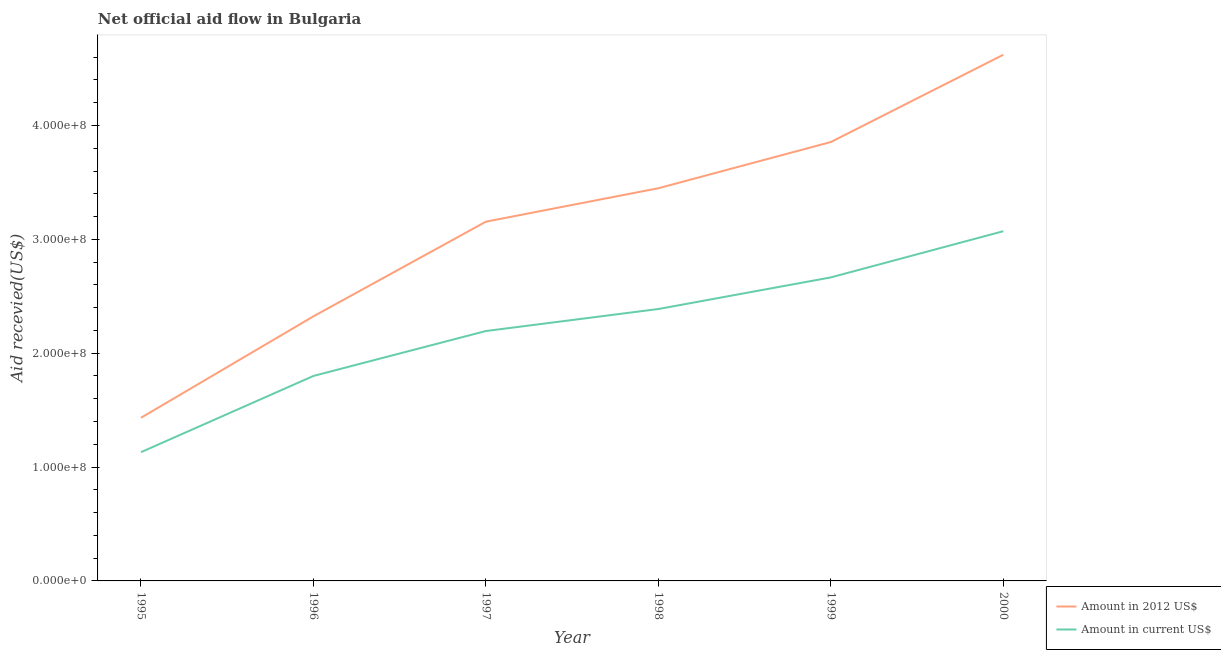Does the line corresponding to amount of aid received(expressed in 2012 us$) intersect with the line corresponding to amount of aid received(expressed in us$)?
Offer a very short reply. No. What is the amount of aid received(expressed in us$) in 2000?
Offer a terse response. 3.07e+08. Across all years, what is the maximum amount of aid received(expressed in 2012 us$)?
Keep it short and to the point. 4.62e+08. Across all years, what is the minimum amount of aid received(expressed in 2012 us$)?
Give a very brief answer. 1.43e+08. In which year was the amount of aid received(expressed in us$) maximum?
Make the answer very short. 2000. What is the total amount of aid received(expressed in 2012 us$) in the graph?
Your answer should be compact. 1.88e+09. What is the difference between the amount of aid received(expressed in us$) in 1997 and that in 1998?
Provide a short and direct response. -1.93e+07. What is the difference between the amount of aid received(expressed in 2012 us$) in 1999 and the amount of aid received(expressed in us$) in 1997?
Your answer should be compact. 1.66e+08. What is the average amount of aid received(expressed in 2012 us$) per year?
Keep it short and to the point. 3.14e+08. In the year 2000, what is the difference between the amount of aid received(expressed in 2012 us$) and amount of aid received(expressed in us$)?
Provide a succinct answer. 1.55e+08. In how many years, is the amount of aid received(expressed in us$) greater than 120000000 US$?
Ensure brevity in your answer.  5. What is the ratio of the amount of aid received(expressed in us$) in 1996 to that in 2000?
Your response must be concise. 0.59. Is the difference between the amount of aid received(expressed in us$) in 1995 and 1998 greater than the difference between the amount of aid received(expressed in 2012 us$) in 1995 and 1998?
Make the answer very short. Yes. What is the difference between the highest and the second highest amount of aid received(expressed in 2012 us$)?
Your answer should be very brief. 7.66e+07. What is the difference between the highest and the lowest amount of aid received(expressed in us$)?
Offer a terse response. 1.94e+08. In how many years, is the amount of aid received(expressed in us$) greater than the average amount of aid received(expressed in us$) taken over all years?
Your answer should be very brief. 3. Is the sum of the amount of aid received(expressed in 2012 us$) in 1997 and 1999 greater than the maximum amount of aid received(expressed in us$) across all years?
Your answer should be compact. Yes. Is the amount of aid received(expressed in 2012 us$) strictly greater than the amount of aid received(expressed in us$) over the years?
Give a very brief answer. Yes. Does the graph contain any zero values?
Your answer should be compact. No. Does the graph contain grids?
Make the answer very short. No. How many legend labels are there?
Your answer should be very brief. 2. How are the legend labels stacked?
Offer a terse response. Vertical. What is the title of the graph?
Give a very brief answer. Net official aid flow in Bulgaria. Does "Highest 10% of population" appear as one of the legend labels in the graph?
Give a very brief answer. No. What is the label or title of the X-axis?
Ensure brevity in your answer.  Year. What is the label or title of the Y-axis?
Provide a short and direct response. Aid recevied(US$). What is the Aid recevied(US$) in Amount in 2012 US$ in 1995?
Offer a very short reply. 1.43e+08. What is the Aid recevied(US$) in Amount in current US$ in 1995?
Make the answer very short. 1.13e+08. What is the Aid recevied(US$) of Amount in 2012 US$ in 1996?
Offer a very short reply. 2.32e+08. What is the Aid recevied(US$) in Amount in current US$ in 1996?
Your answer should be compact. 1.80e+08. What is the Aid recevied(US$) in Amount in 2012 US$ in 1997?
Your answer should be very brief. 3.16e+08. What is the Aid recevied(US$) of Amount in current US$ in 1997?
Ensure brevity in your answer.  2.19e+08. What is the Aid recevied(US$) in Amount in 2012 US$ in 1998?
Offer a terse response. 3.45e+08. What is the Aid recevied(US$) of Amount in current US$ in 1998?
Offer a terse response. 2.39e+08. What is the Aid recevied(US$) in Amount in 2012 US$ in 1999?
Ensure brevity in your answer.  3.85e+08. What is the Aid recevied(US$) of Amount in current US$ in 1999?
Your response must be concise. 2.67e+08. What is the Aid recevied(US$) in Amount in 2012 US$ in 2000?
Your answer should be very brief. 4.62e+08. What is the Aid recevied(US$) of Amount in current US$ in 2000?
Offer a terse response. 3.07e+08. Across all years, what is the maximum Aid recevied(US$) in Amount in 2012 US$?
Offer a very short reply. 4.62e+08. Across all years, what is the maximum Aid recevied(US$) in Amount in current US$?
Offer a very short reply. 3.07e+08. Across all years, what is the minimum Aid recevied(US$) in Amount in 2012 US$?
Offer a terse response. 1.43e+08. Across all years, what is the minimum Aid recevied(US$) in Amount in current US$?
Your answer should be compact. 1.13e+08. What is the total Aid recevied(US$) in Amount in 2012 US$ in the graph?
Make the answer very short. 1.88e+09. What is the total Aid recevied(US$) of Amount in current US$ in the graph?
Your answer should be compact. 1.33e+09. What is the difference between the Aid recevied(US$) in Amount in 2012 US$ in 1995 and that in 1996?
Make the answer very short. -8.91e+07. What is the difference between the Aid recevied(US$) in Amount in current US$ in 1995 and that in 1996?
Your response must be concise. -6.70e+07. What is the difference between the Aid recevied(US$) in Amount in 2012 US$ in 1995 and that in 1997?
Make the answer very short. -1.72e+08. What is the difference between the Aid recevied(US$) of Amount in current US$ in 1995 and that in 1997?
Provide a succinct answer. -1.06e+08. What is the difference between the Aid recevied(US$) of Amount in 2012 US$ in 1995 and that in 1998?
Offer a very short reply. -2.02e+08. What is the difference between the Aid recevied(US$) of Amount in current US$ in 1995 and that in 1998?
Your response must be concise. -1.26e+08. What is the difference between the Aid recevied(US$) in Amount in 2012 US$ in 1995 and that in 1999?
Provide a succinct answer. -2.42e+08. What is the difference between the Aid recevied(US$) in Amount in current US$ in 1995 and that in 1999?
Keep it short and to the point. -1.53e+08. What is the difference between the Aid recevied(US$) of Amount in 2012 US$ in 1995 and that in 2000?
Ensure brevity in your answer.  -3.19e+08. What is the difference between the Aid recevied(US$) of Amount in current US$ in 1995 and that in 2000?
Ensure brevity in your answer.  -1.94e+08. What is the difference between the Aid recevied(US$) in Amount in 2012 US$ in 1996 and that in 1997?
Provide a short and direct response. -8.31e+07. What is the difference between the Aid recevied(US$) in Amount in current US$ in 1996 and that in 1997?
Ensure brevity in your answer.  -3.94e+07. What is the difference between the Aid recevied(US$) in Amount in 2012 US$ in 1996 and that in 1998?
Ensure brevity in your answer.  -1.12e+08. What is the difference between the Aid recevied(US$) of Amount in current US$ in 1996 and that in 1998?
Provide a short and direct response. -5.88e+07. What is the difference between the Aid recevied(US$) in Amount in 2012 US$ in 1996 and that in 1999?
Offer a very short reply. -1.53e+08. What is the difference between the Aid recevied(US$) in Amount in current US$ in 1996 and that in 1999?
Provide a succinct answer. -8.65e+07. What is the difference between the Aid recevied(US$) of Amount in 2012 US$ in 1996 and that in 2000?
Provide a succinct answer. -2.30e+08. What is the difference between the Aid recevied(US$) in Amount in current US$ in 1996 and that in 2000?
Ensure brevity in your answer.  -1.27e+08. What is the difference between the Aid recevied(US$) of Amount in 2012 US$ in 1997 and that in 1998?
Offer a very short reply. -2.94e+07. What is the difference between the Aid recevied(US$) of Amount in current US$ in 1997 and that in 1998?
Your answer should be very brief. -1.93e+07. What is the difference between the Aid recevied(US$) in Amount in 2012 US$ in 1997 and that in 1999?
Provide a short and direct response. -6.99e+07. What is the difference between the Aid recevied(US$) of Amount in current US$ in 1997 and that in 1999?
Give a very brief answer. -4.71e+07. What is the difference between the Aid recevied(US$) in Amount in 2012 US$ in 1997 and that in 2000?
Provide a short and direct response. -1.47e+08. What is the difference between the Aid recevied(US$) in Amount in current US$ in 1997 and that in 2000?
Ensure brevity in your answer.  -8.77e+07. What is the difference between the Aid recevied(US$) in Amount in 2012 US$ in 1998 and that in 1999?
Keep it short and to the point. -4.06e+07. What is the difference between the Aid recevied(US$) in Amount in current US$ in 1998 and that in 1999?
Your response must be concise. -2.78e+07. What is the difference between the Aid recevied(US$) in Amount in 2012 US$ in 1998 and that in 2000?
Your response must be concise. -1.17e+08. What is the difference between the Aid recevied(US$) of Amount in current US$ in 1998 and that in 2000?
Give a very brief answer. -6.83e+07. What is the difference between the Aid recevied(US$) of Amount in 2012 US$ in 1999 and that in 2000?
Provide a short and direct response. -7.66e+07. What is the difference between the Aid recevied(US$) of Amount in current US$ in 1999 and that in 2000?
Provide a succinct answer. -4.06e+07. What is the difference between the Aid recevied(US$) of Amount in 2012 US$ in 1995 and the Aid recevied(US$) of Amount in current US$ in 1996?
Your answer should be very brief. -3.68e+07. What is the difference between the Aid recevied(US$) of Amount in 2012 US$ in 1995 and the Aid recevied(US$) of Amount in current US$ in 1997?
Offer a very short reply. -7.62e+07. What is the difference between the Aid recevied(US$) of Amount in 2012 US$ in 1995 and the Aid recevied(US$) of Amount in current US$ in 1998?
Your answer should be compact. -9.55e+07. What is the difference between the Aid recevied(US$) of Amount in 2012 US$ in 1995 and the Aid recevied(US$) of Amount in current US$ in 1999?
Your response must be concise. -1.23e+08. What is the difference between the Aid recevied(US$) in Amount in 2012 US$ in 1995 and the Aid recevied(US$) in Amount in current US$ in 2000?
Give a very brief answer. -1.64e+08. What is the difference between the Aid recevied(US$) of Amount in 2012 US$ in 1996 and the Aid recevied(US$) of Amount in current US$ in 1997?
Your answer should be very brief. 1.29e+07. What is the difference between the Aid recevied(US$) in Amount in 2012 US$ in 1996 and the Aid recevied(US$) in Amount in current US$ in 1998?
Offer a terse response. -6.42e+06. What is the difference between the Aid recevied(US$) of Amount in 2012 US$ in 1996 and the Aid recevied(US$) of Amount in current US$ in 1999?
Offer a very short reply. -3.42e+07. What is the difference between the Aid recevied(US$) in Amount in 2012 US$ in 1996 and the Aid recevied(US$) in Amount in current US$ in 2000?
Your answer should be very brief. -7.48e+07. What is the difference between the Aid recevied(US$) of Amount in 2012 US$ in 1997 and the Aid recevied(US$) of Amount in current US$ in 1998?
Offer a terse response. 7.67e+07. What is the difference between the Aid recevied(US$) of Amount in 2012 US$ in 1997 and the Aid recevied(US$) of Amount in current US$ in 1999?
Ensure brevity in your answer.  4.90e+07. What is the difference between the Aid recevied(US$) in Amount in 2012 US$ in 1997 and the Aid recevied(US$) in Amount in current US$ in 2000?
Provide a succinct answer. 8.37e+06. What is the difference between the Aid recevied(US$) in Amount in 2012 US$ in 1998 and the Aid recevied(US$) in Amount in current US$ in 1999?
Offer a very short reply. 7.83e+07. What is the difference between the Aid recevied(US$) in Amount in 2012 US$ in 1998 and the Aid recevied(US$) in Amount in current US$ in 2000?
Offer a terse response. 3.77e+07. What is the difference between the Aid recevied(US$) in Amount in 2012 US$ in 1999 and the Aid recevied(US$) in Amount in current US$ in 2000?
Ensure brevity in your answer.  7.83e+07. What is the average Aid recevied(US$) in Amount in 2012 US$ per year?
Provide a short and direct response. 3.14e+08. What is the average Aid recevied(US$) of Amount in current US$ per year?
Provide a short and direct response. 2.21e+08. In the year 1995, what is the difference between the Aid recevied(US$) of Amount in 2012 US$ and Aid recevied(US$) of Amount in current US$?
Provide a succinct answer. 3.02e+07. In the year 1996, what is the difference between the Aid recevied(US$) in Amount in 2012 US$ and Aid recevied(US$) in Amount in current US$?
Provide a succinct answer. 5.24e+07. In the year 1997, what is the difference between the Aid recevied(US$) in Amount in 2012 US$ and Aid recevied(US$) in Amount in current US$?
Give a very brief answer. 9.60e+07. In the year 1998, what is the difference between the Aid recevied(US$) in Amount in 2012 US$ and Aid recevied(US$) in Amount in current US$?
Keep it short and to the point. 1.06e+08. In the year 1999, what is the difference between the Aid recevied(US$) in Amount in 2012 US$ and Aid recevied(US$) in Amount in current US$?
Make the answer very short. 1.19e+08. In the year 2000, what is the difference between the Aid recevied(US$) of Amount in 2012 US$ and Aid recevied(US$) of Amount in current US$?
Make the answer very short. 1.55e+08. What is the ratio of the Aid recevied(US$) in Amount in 2012 US$ in 1995 to that in 1996?
Keep it short and to the point. 0.62. What is the ratio of the Aid recevied(US$) in Amount in current US$ in 1995 to that in 1996?
Your answer should be compact. 0.63. What is the ratio of the Aid recevied(US$) in Amount in 2012 US$ in 1995 to that in 1997?
Offer a very short reply. 0.45. What is the ratio of the Aid recevied(US$) of Amount in current US$ in 1995 to that in 1997?
Ensure brevity in your answer.  0.52. What is the ratio of the Aid recevied(US$) in Amount in 2012 US$ in 1995 to that in 1998?
Offer a very short reply. 0.42. What is the ratio of the Aid recevied(US$) in Amount in current US$ in 1995 to that in 1998?
Provide a short and direct response. 0.47. What is the ratio of the Aid recevied(US$) of Amount in 2012 US$ in 1995 to that in 1999?
Your answer should be compact. 0.37. What is the ratio of the Aid recevied(US$) in Amount in current US$ in 1995 to that in 1999?
Offer a terse response. 0.42. What is the ratio of the Aid recevied(US$) in Amount in 2012 US$ in 1995 to that in 2000?
Your answer should be very brief. 0.31. What is the ratio of the Aid recevied(US$) in Amount in current US$ in 1995 to that in 2000?
Offer a terse response. 0.37. What is the ratio of the Aid recevied(US$) in Amount in 2012 US$ in 1996 to that in 1997?
Keep it short and to the point. 0.74. What is the ratio of the Aid recevied(US$) in Amount in current US$ in 1996 to that in 1997?
Your answer should be compact. 0.82. What is the ratio of the Aid recevied(US$) in Amount in 2012 US$ in 1996 to that in 1998?
Provide a succinct answer. 0.67. What is the ratio of the Aid recevied(US$) of Amount in current US$ in 1996 to that in 1998?
Provide a succinct answer. 0.75. What is the ratio of the Aid recevied(US$) in Amount in 2012 US$ in 1996 to that in 1999?
Your answer should be compact. 0.6. What is the ratio of the Aid recevied(US$) of Amount in current US$ in 1996 to that in 1999?
Your answer should be very brief. 0.68. What is the ratio of the Aid recevied(US$) of Amount in 2012 US$ in 1996 to that in 2000?
Offer a terse response. 0.5. What is the ratio of the Aid recevied(US$) of Amount in current US$ in 1996 to that in 2000?
Give a very brief answer. 0.59. What is the ratio of the Aid recevied(US$) of Amount in 2012 US$ in 1997 to that in 1998?
Offer a very short reply. 0.91. What is the ratio of the Aid recevied(US$) of Amount in current US$ in 1997 to that in 1998?
Your answer should be very brief. 0.92. What is the ratio of the Aid recevied(US$) in Amount in 2012 US$ in 1997 to that in 1999?
Your answer should be compact. 0.82. What is the ratio of the Aid recevied(US$) in Amount in current US$ in 1997 to that in 1999?
Your answer should be compact. 0.82. What is the ratio of the Aid recevied(US$) of Amount in 2012 US$ in 1997 to that in 2000?
Offer a terse response. 0.68. What is the ratio of the Aid recevied(US$) of Amount in current US$ in 1997 to that in 2000?
Your answer should be compact. 0.71. What is the ratio of the Aid recevied(US$) in Amount in 2012 US$ in 1998 to that in 1999?
Provide a succinct answer. 0.89. What is the ratio of the Aid recevied(US$) of Amount in current US$ in 1998 to that in 1999?
Offer a terse response. 0.9. What is the ratio of the Aid recevied(US$) in Amount in 2012 US$ in 1998 to that in 2000?
Give a very brief answer. 0.75. What is the ratio of the Aid recevied(US$) of Amount in current US$ in 1998 to that in 2000?
Provide a short and direct response. 0.78. What is the ratio of the Aid recevied(US$) of Amount in 2012 US$ in 1999 to that in 2000?
Keep it short and to the point. 0.83. What is the ratio of the Aid recevied(US$) of Amount in current US$ in 1999 to that in 2000?
Offer a terse response. 0.87. What is the difference between the highest and the second highest Aid recevied(US$) of Amount in 2012 US$?
Provide a short and direct response. 7.66e+07. What is the difference between the highest and the second highest Aid recevied(US$) of Amount in current US$?
Keep it short and to the point. 4.06e+07. What is the difference between the highest and the lowest Aid recevied(US$) of Amount in 2012 US$?
Your response must be concise. 3.19e+08. What is the difference between the highest and the lowest Aid recevied(US$) of Amount in current US$?
Your answer should be compact. 1.94e+08. 